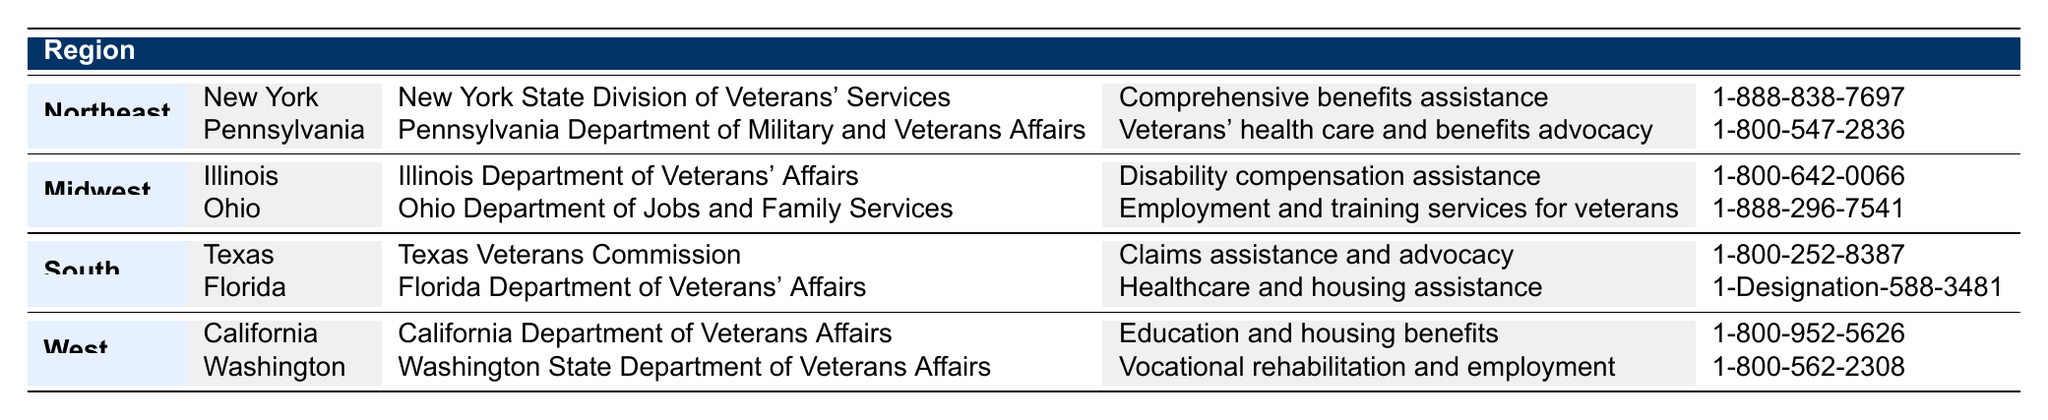What is the program name for Texas in the South region? In the South region, Texas has a program listed, which is found by examining the respective row under the South category. The name of the program is "Texas Veterans Commission."
Answer: Texas Veterans Commission How many assistance programs are listed for the Northeast region? In the Northeast region, there are two programs listed, one for New York and one for Pennsylvania. By counting these entries, we determine that there are a total of two programs.
Answer: 2 Does Illinois offer healthcare assistance to veterans? The table shows that Illinois' program is "Disability compensation assistance," which does not specifically mention healthcare assistance. Therefore, the answer is no, Illinois does not offer healthcare assistance to veterans.
Answer: No Which state in the Midwest offers employment and training services? The state of Ohio in the Midwest region is noted in the table for its program called "Ohio Department of Jobs and Family Services," which provides "Employment and training services for veterans." Thus, the answer is Ohio.
Answer: Ohio What type of services does Florida's program provide? The program for Florida, which is the "Florida Department of Veterans' Affairs," provides "Healthcare and housing assistance." This information can be directly found in Florida's row under the South region in the table.
Answer: Healthcare and housing assistance How does the number of programs in the West compare to the Northeast? In the West region, there are two programs listed (California and Washington). In the Northeast region, there are also two programs (New York and Pennsylvania). Therefore, the number of programs in both regions is equal.
Answer: Equal Is there a program in the South region that assists with claims? Referring to the South region, Texas' program named "Texas Veterans Commission" provides "Claims assistance and advocacy," indicating that there is indeed a program assisting with claims.
Answer: Yes Which region has the most diverse range of service types as represented in the table? By reviewing the service types listed for each region, the Northeast has programs for both comprehensive benefits assistance and health care and benefits advocacy. In contrast, other regions provide more specialized services, such as vocational rehabilitation or employment assistance. However, since the Northeast has two different services types, it can be concluded that it has a diverse range.
Answer: Northeast 